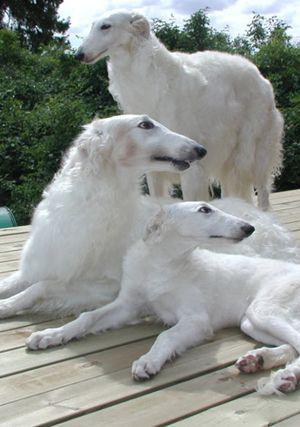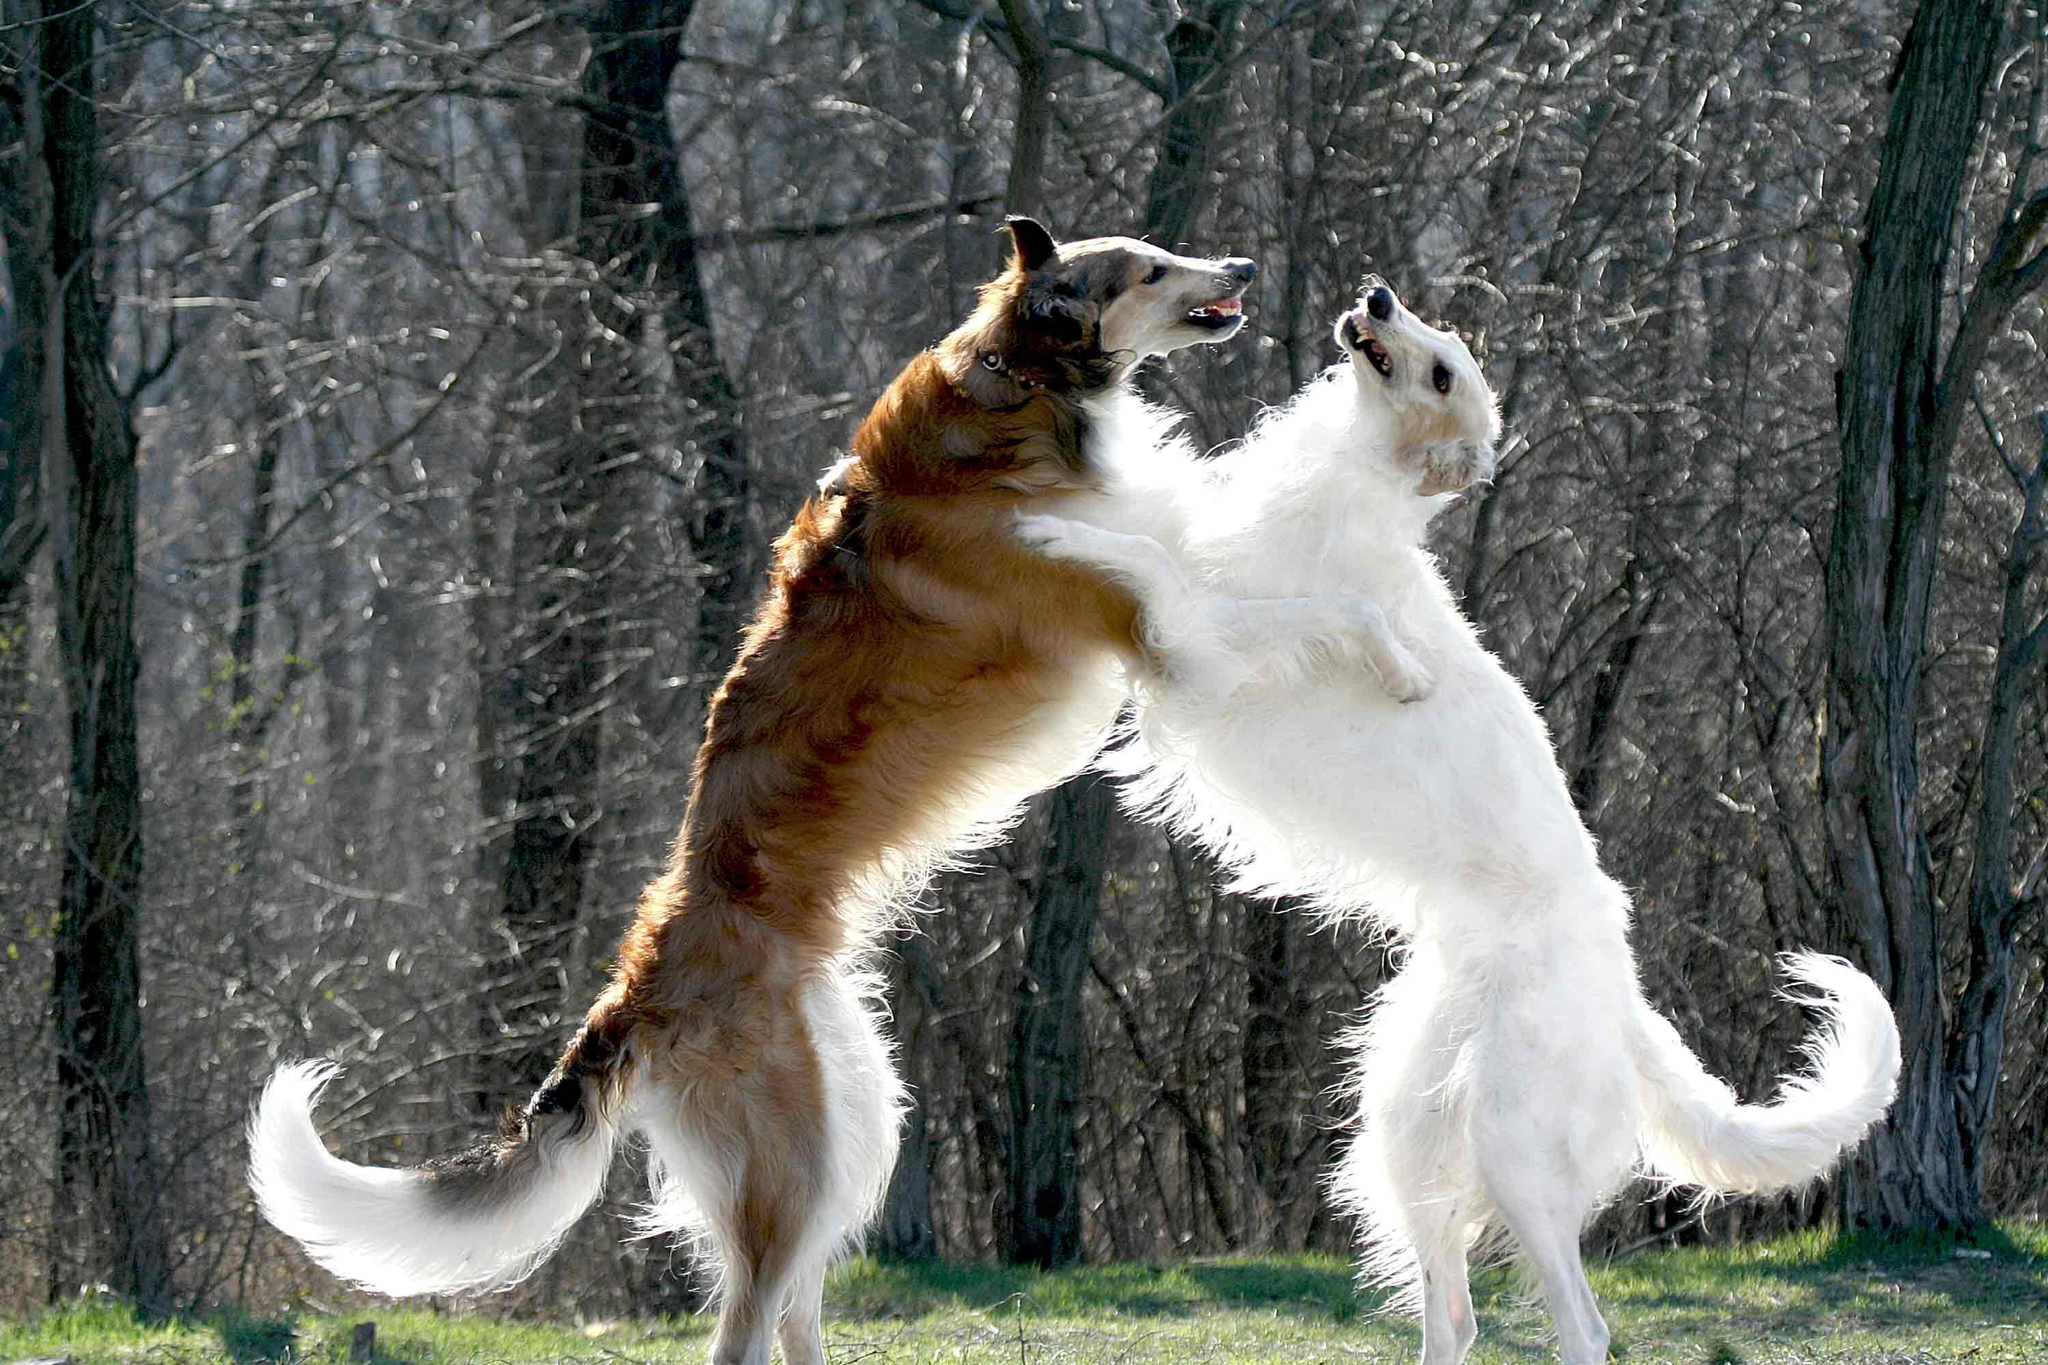The first image is the image on the left, the second image is the image on the right. For the images shown, is this caption "An image shows exactly two hounds, which face one another." true? Answer yes or no. Yes. The first image is the image on the left, the second image is the image on the right. Considering the images on both sides, is "One of the pictures contains two dogs." valid? Answer yes or no. Yes. 